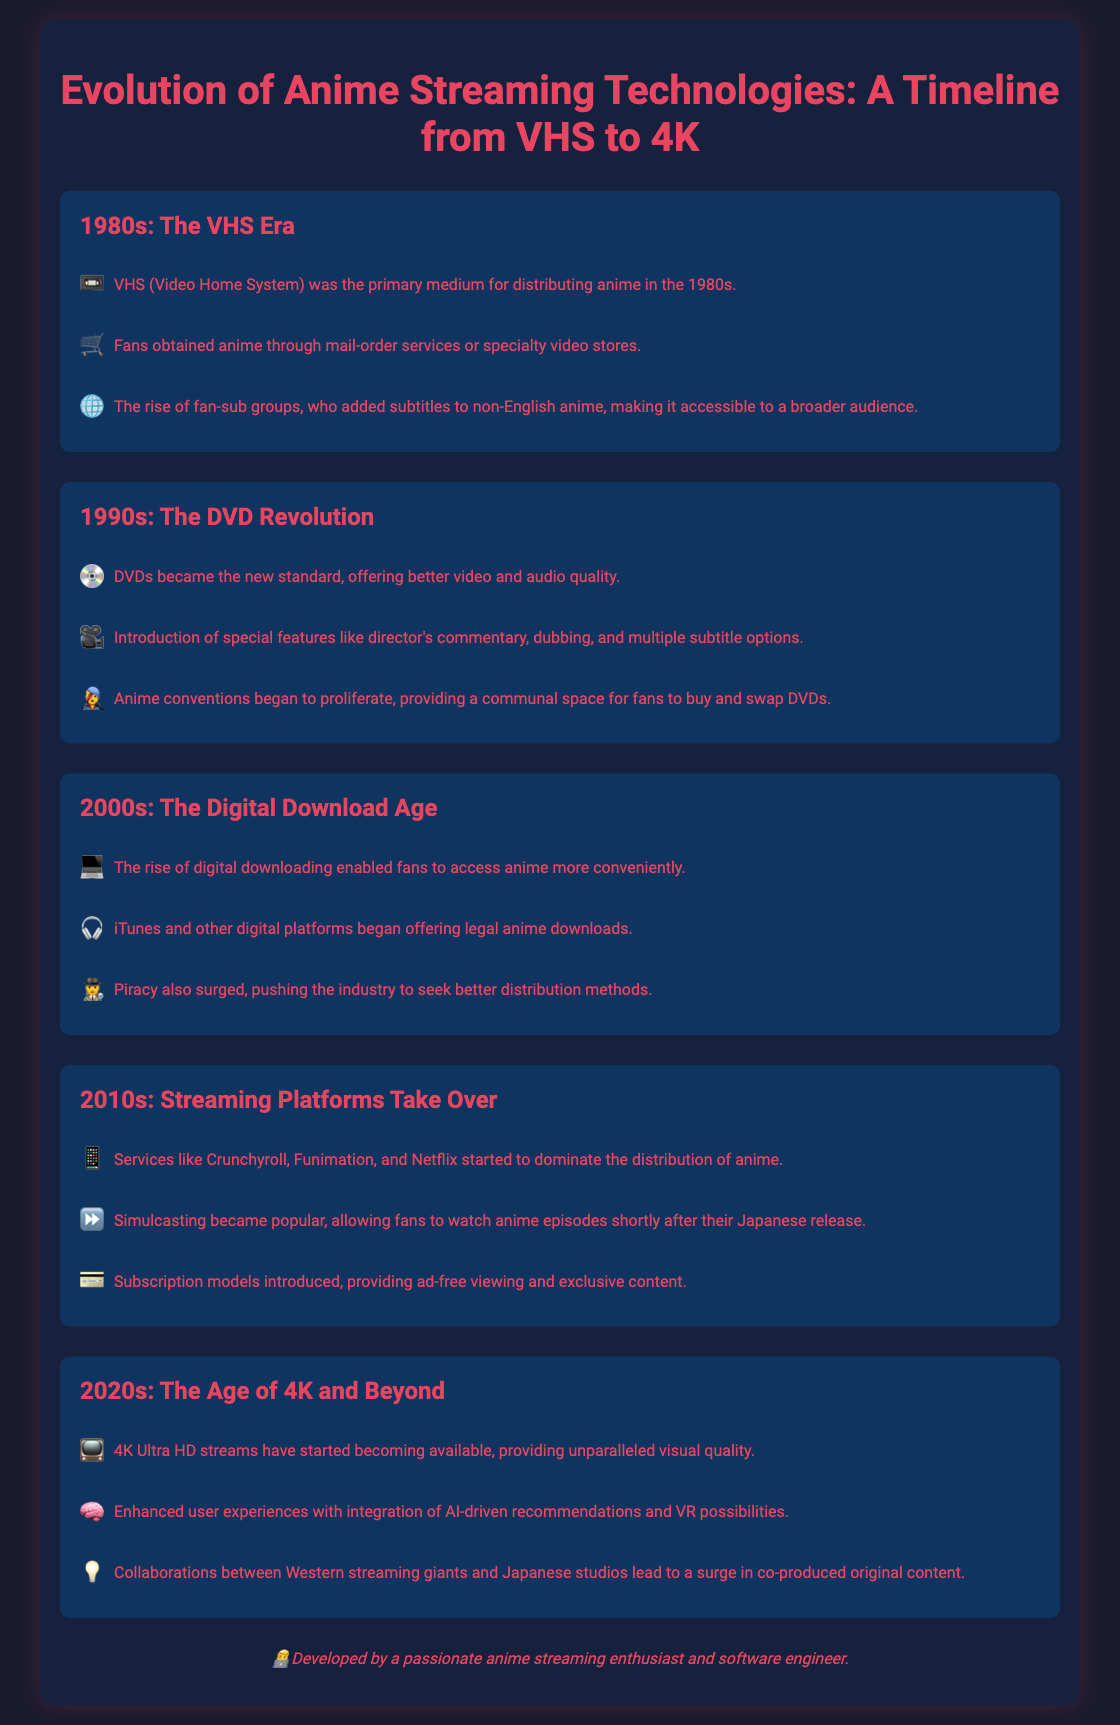What was the primary medium for distributing anime in the 1980s? The primary medium for distributing anime in the 1980s was VHS (Video Home System).
Answer: VHS What notable feature was introduced with DVDs in the 1990s? DVDs introduced special features like director's commentary, dubbing, and multiple subtitle options.
Answer: Special features Which platforms started to dominate anime distribution in the 2010s? Services like Crunchyroll, Funimation, and Netflix started to dominate the distribution of anime.
Answer: Crunchyroll, Funimation, Netflix What type of quality started becoming available in the 2020s? 4K Ultra HD streams have started becoming available.
Answer: 4K Ultra HD What caused the rise of fan-sub groups in the 1980s? Fan-sub groups rose due to the need to add subtitles to non-English anime, making it accessible to a broader audience.
Answer: Subtitles What trend allowed fans to watch anime episodes shortly after their Japanese release in the 2010s? Simulcasting became popular in the 2010s, allowing immediate viewing of episodes.
Answer: Simulcasting What enhancement to user experience is mentioned for the 2020s? AI-driven recommendations and VR possibilities are enhancements mentioned for the user experience in the 2020s.
Answer: AI-driven recommendations During the 2000s, what significant challenge pushed the industry to seek better distribution methods? Piracy surged in the 2000s, pushing the industry toward better distribution.
Answer: Piracy Which era saw the introduction of the DVD format? The DVD Revolution in the 1990s saw the introduction of the DVD format.
Answer: 1990s 